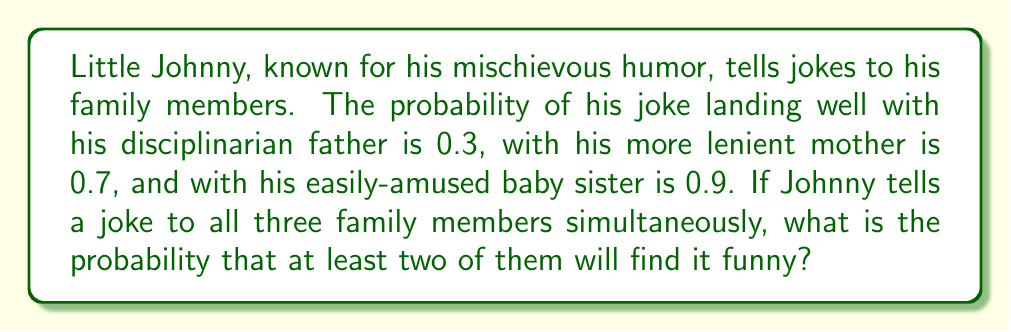Provide a solution to this math problem. Let's approach this step-by-step using the complement method:

1) First, let's define our events:
   F = Father finds it funny
   M = Mother finds it funny
   S = Sister finds it funny

2) We're looking for P(at least two find it funny), which is easier to calculate as:
   1 - P(less than two find it funny)

3) "Less than two find it funny" can happen in two ways:
   a) Nobody finds it funny
   b) Exactly one person finds it funny

4) Let's calculate these probabilities:

   a) P(nobody finds it funny) = P(F' ∩ M' ∩ S')
      = (1-0.3) * (1-0.7) * (1-0.9) = 0.7 * 0.3 * 0.1 = 0.021

   b) P(exactly one finds it funny) = P(F ∩ M' ∩ S') + P(F' ∩ M ∩ S') + P(F' ∩ M' ∩ S)
      = 0.3 * 0.3 * 0.1 + 0.7 * 0.7 * 0.1 + 0.7 * 0.3 * 0.9
      = 0.009 + 0.049 + 0.189 = 0.247

5) Therefore, P(less than two find it funny) = 0.021 + 0.247 = 0.268

6) Finally, P(at least two find it funny) = 1 - 0.268 = 0.732
Answer: 0.732 